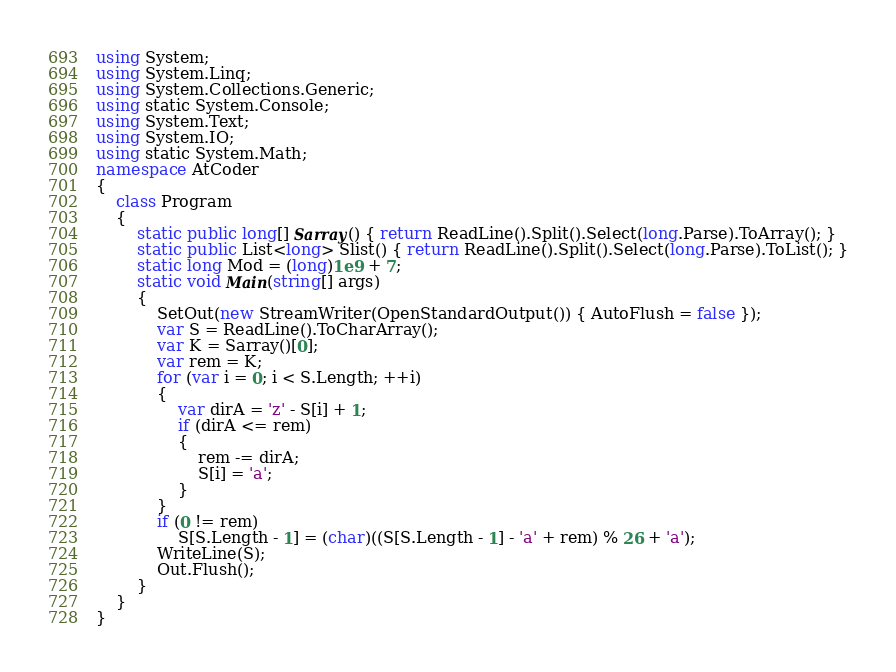Convert code to text. <code><loc_0><loc_0><loc_500><loc_500><_C#_>using System;
using System.Linq;
using System.Collections.Generic;
using static System.Console;
using System.Text;
using System.IO;
using static System.Math;
namespace AtCoder
{
    class Program
    {
        static public long[] Sarray() { return ReadLine().Split().Select(long.Parse).ToArray(); }
        static public List<long> Slist() { return ReadLine().Split().Select(long.Parse).ToList(); }
        static long Mod = (long)1e9 + 7;
        static void Main(string[] args)
        {
            SetOut(new StreamWriter(OpenStandardOutput()) { AutoFlush = false });
            var S = ReadLine().ToCharArray();
            var K = Sarray()[0];
            var rem = K;
            for (var i = 0; i < S.Length; ++i)
            {
                var dirA = 'z' - S[i] + 1;
                if (dirA <= rem)
                {
                    rem -= dirA;
                    S[i] = 'a';
                }
            }
            if (0 != rem)
                S[S.Length - 1] = (char)((S[S.Length - 1] - 'a' + rem) % 26 + 'a');
            WriteLine(S);
            Out.Flush();
        }
    }
}</code> 